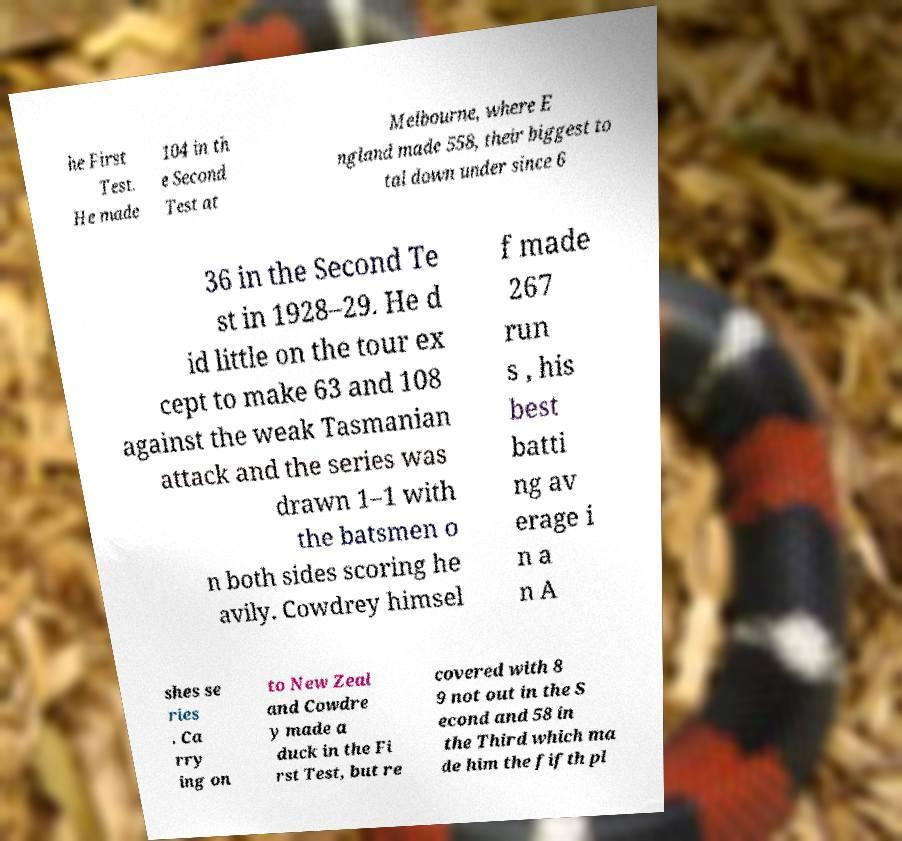Can you read and provide the text displayed in the image?This photo seems to have some interesting text. Can you extract and type it out for me? he First Test. He made 104 in th e Second Test at Melbourne, where E ngland made 558, their biggest to tal down under since 6 36 in the Second Te st in 1928–29. He d id little on the tour ex cept to make 63 and 108 against the weak Tasmanian attack and the series was drawn 1–1 with the batsmen o n both sides scoring he avily. Cowdrey himsel f made 267 run s , his best batti ng av erage i n a n A shes se ries . Ca rry ing on to New Zeal and Cowdre y made a duck in the Fi rst Test, but re covered with 8 9 not out in the S econd and 58 in the Third which ma de him the fifth pl 